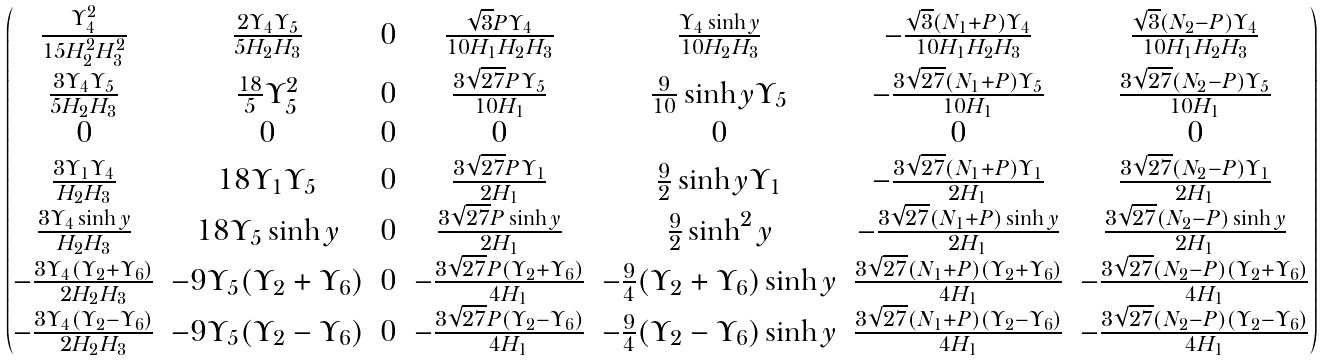<formula> <loc_0><loc_0><loc_500><loc_500>\begin{pmatrix} \frac { \Upsilon _ { 4 } ^ { 2 } } { 1 5 H _ { 2 } ^ { 2 } H _ { 3 } ^ { 2 } } & \frac { 2 \Upsilon _ { 4 } \Upsilon _ { 5 } } { 5 H _ { 2 } H _ { 3 } } & 0 & \frac { \sqrt { 3 } P \Upsilon _ { 4 } } { 1 0 H _ { 1 } H _ { 2 } H _ { 3 } } & \frac { \Upsilon _ { 4 } \sinh y } { 1 0 H _ { 2 } H _ { 3 } } & - \frac { \sqrt { 3 } ( N _ { 1 } + P ) \Upsilon _ { 4 } } { 1 0 H _ { 1 } H _ { 2 } H _ { 3 } } & \frac { \sqrt { 3 } ( N _ { 2 } - P ) \Upsilon _ { 4 } } { 1 0 H _ { 1 } H _ { 2 } H _ { 3 } } \\ \frac { 3 \Upsilon _ { 4 } \Upsilon _ { 5 } } { 5 H _ { 2 } H _ { 3 } } & \frac { 1 8 } { 5 } \Upsilon _ { 5 } ^ { 2 } & 0 & \frac { 3 \sqrt { 2 7 } P \Upsilon _ { 5 } } { 1 0 H _ { 1 } } & \frac { 9 } { 1 0 } \sinh y \Upsilon _ { 5 } & - \frac { 3 \sqrt { 2 7 } ( N _ { 1 } + P ) \Upsilon _ { 5 } } { 1 0 H _ { 1 } } & \frac { 3 \sqrt { 2 7 } ( N _ { 2 } - P ) \Upsilon _ { 5 } } { 1 0 H _ { 1 } } \\ 0 & 0 & 0 & 0 & 0 & 0 & 0 \\ \frac { 3 \Upsilon _ { 1 } \Upsilon _ { 4 } } { H _ { 2 } H _ { 3 } } & 1 8 \Upsilon _ { 1 } \Upsilon _ { 5 } & 0 & \frac { 3 \sqrt { 2 7 } P \Upsilon _ { 1 } } { 2 H _ { 1 } } & \frac { 9 } { 2 } \sinh y \Upsilon _ { 1 } & - \frac { 3 \sqrt { 2 7 } ( N _ { 1 } + P ) \Upsilon _ { 1 } } { 2 H _ { 1 } } & \frac { 3 \sqrt { 2 7 } ( N _ { 2 } - P ) \Upsilon _ { 1 } } { 2 H _ { 1 } } \\ \frac { 3 \Upsilon _ { 4 } \sinh y } { H _ { 2 } H _ { 3 } } & 1 8 \Upsilon _ { 5 } \sinh y & 0 & \frac { 3 \sqrt { 2 7 } P \sinh y } { 2 H _ { 1 } } & \frac { 9 } { 2 } \sinh ^ { 2 } y & - \frac { 3 \sqrt { 2 7 } ( N _ { 1 } + P ) \sinh y } { 2 H _ { 1 } } & \frac { 3 \sqrt { 2 7 } ( N _ { 2 } - P ) \sinh y } { 2 H _ { 1 } } \\ - \frac { 3 \Upsilon _ { 4 } ( \Upsilon _ { 2 } + \Upsilon _ { 6 } ) } { 2 H _ { 2 } H _ { 3 } } & - 9 \Upsilon _ { 5 } ( \Upsilon _ { 2 } + \Upsilon _ { 6 } ) & 0 & - \frac { 3 \sqrt { 2 7 } P ( \Upsilon _ { 2 } + \Upsilon _ { 6 } ) } { 4 H _ { 1 } } & - \frac { 9 } { 4 } ( \Upsilon _ { 2 } + \Upsilon _ { 6 } ) \sinh y & \frac { 3 \sqrt { 2 7 } ( N _ { 1 } + P ) ( \Upsilon _ { 2 } + \Upsilon _ { 6 } ) } { 4 H _ { 1 } } & - \frac { 3 \sqrt { 2 7 } ( N _ { 2 } - P ) ( \Upsilon _ { 2 } + \Upsilon _ { 6 } ) } { 4 H _ { 1 } } \\ - \frac { 3 \Upsilon _ { 4 } ( \Upsilon _ { 2 } - \Upsilon _ { 6 } ) } { 2 H _ { 2 } H _ { 3 } } & - 9 \Upsilon _ { 5 } ( \Upsilon _ { 2 } - \Upsilon _ { 6 } ) & 0 & - \frac { 3 \sqrt { 2 7 } P ( \Upsilon _ { 2 } - \Upsilon _ { 6 } ) } { 4 H _ { 1 } } & - \frac { 9 } { 4 } ( \Upsilon _ { 2 } - \Upsilon _ { 6 } ) \sinh y & \frac { 3 \sqrt { 2 7 } ( N _ { 1 } + P ) ( \Upsilon _ { 2 } - \Upsilon _ { 6 } ) } { 4 H _ { 1 } } & - \frac { 3 \sqrt { 2 7 } ( N _ { 2 } - P ) ( \Upsilon _ { 2 } - \Upsilon _ { 6 } ) } { 4 H _ { 1 } } \end{pmatrix}</formula> 